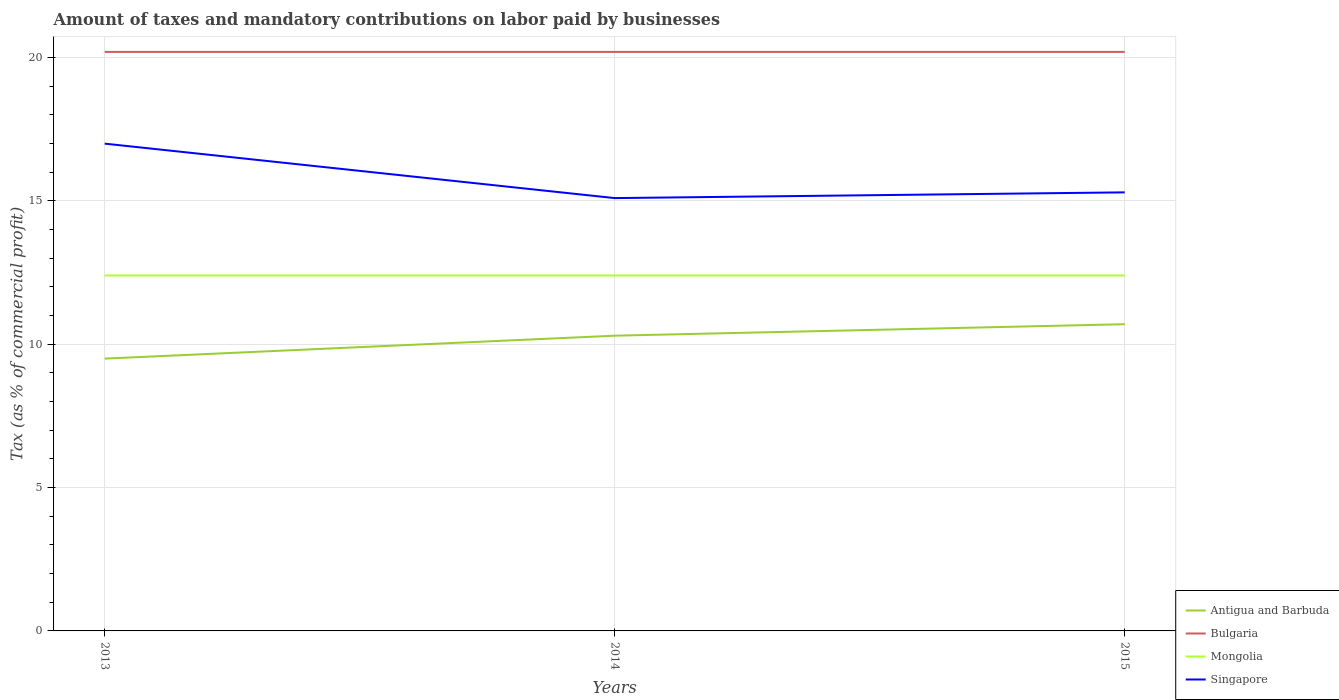What is the total percentage of taxes paid by businesses in Singapore in the graph?
Offer a very short reply. -0.2. What is the difference between the highest and the lowest percentage of taxes paid by businesses in Bulgaria?
Provide a succinct answer. 0. Is the percentage of taxes paid by businesses in Antigua and Barbuda strictly greater than the percentage of taxes paid by businesses in Mongolia over the years?
Ensure brevity in your answer.  Yes. Are the values on the major ticks of Y-axis written in scientific E-notation?
Provide a short and direct response. No. How many legend labels are there?
Provide a short and direct response. 4. What is the title of the graph?
Your answer should be compact. Amount of taxes and mandatory contributions on labor paid by businesses. Does "Bermuda" appear as one of the legend labels in the graph?
Provide a short and direct response. No. What is the label or title of the Y-axis?
Keep it short and to the point. Tax (as % of commercial profit). What is the Tax (as % of commercial profit) in Bulgaria in 2013?
Your answer should be very brief. 20.2. What is the Tax (as % of commercial profit) in Mongolia in 2013?
Offer a very short reply. 12.4. What is the Tax (as % of commercial profit) in Singapore in 2013?
Your answer should be compact. 17. What is the Tax (as % of commercial profit) of Antigua and Barbuda in 2014?
Keep it short and to the point. 10.3. What is the Tax (as % of commercial profit) of Bulgaria in 2014?
Make the answer very short. 20.2. What is the Tax (as % of commercial profit) of Mongolia in 2014?
Keep it short and to the point. 12.4. What is the Tax (as % of commercial profit) in Singapore in 2014?
Your answer should be very brief. 15.1. What is the Tax (as % of commercial profit) of Bulgaria in 2015?
Provide a short and direct response. 20.2. What is the Tax (as % of commercial profit) in Mongolia in 2015?
Keep it short and to the point. 12.4. Across all years, what is the maximum Tax (as % of commercial profit) in Bulgaria?
Provide a succinct answer. 20.2. Across all years, what is the maximum Tax (as % of commercial profit) in Mongolia?
Provide a succinct answer. 12.4. Across all years, what is the maximum Tax (as % of commercial profit) in Singapore?
Provide a succinct answer. 17. Across all years, what is the minimum Tax (as % of commercial profit) of Antigua and Barbuda?
Provide a succinct answer. 9.5. Across all years, what is the minimum Tax (as % of commercial profit) in Bulgaria?
Offer a very short reply. 20.2. Across all years, what is the minimum Tax (as % of commercial profit) in Singapore?
Your answer should be compact. 15.1. What is the total Tax (as % of commercial profit) in Antigua and Barbuda in the graph?
Provide a succinct answer. 30.5. What is the total Tax (as % of commercial profit) in Bulgaria in the graph?
Offer a terse response. 60.6. What is the total Tax (as % of commercial profit) in Mongolia in the graph?
Your response must be concise. 37.2. What is the total Tax (as % of commercial profit) of Singapore in the graph?
Your response must be concise. 47.4. What is the difference between the Tax (as % of commercial profit) of Mongolia in 2013 and that in 2014?
Offer a terse response. 0. What is the difference between the Tax (as % of commercial profit) of Singapore in 2013 and that in 2015?
Ensure brevity in your answer.  1.7. What is the difference between the Tax (as % of commercial profit) of Antigua and Barbuda in 2014 and that in 2015?
Ensure brevity in your answer.  -0.4. What is the difference between the Tax (as % of commercial profit) in Bulgaria in 2014 and that in 2015?
Provide a succinct answer. 0. What is the difference between the Tax (as % of commercial profit) in Singapore in 2014 and that in 2015?
Your response must be concise. -0.2. What is the difference between the Tax (as % of commercial profit) in Mongolia in 2013 and the Tax (as % of commercial profit) in Singapore in 2014?
Keep it short and to the point. -2.7. What is the difference between the Tax (as % of commercial profit) in Antigua and Barbuda in 2013 and the Tax (as % of commercial profit) in Bulgaria in 2015?
Provide a succinct answer. -10.7. What is the difference between the Tax (as % of commercial profit) in Antigua and Barbuda in 2013 and the Tax (as % of commercial profit) in Mongolia in 2015?
Offer a terse response. -2.9. What is the difference between the Tax (as % of commercial profit) in Antigua and Barbuda in 2014 and the Tax (as % of commercial profit) in Bulgaria in 2015?
Provide a succinct answer. -9.9. What is the difference between the Tax (as % of commercial profit) of Bulgaria in 2014 and the Tax (as % of commercial profit) of Mongolia in 2015?
Give a very brief answer. 7.8. What is the average Tax (as % of commercial profit) in Antigua and Barbuda per year?
Your answer should be compact. 10.17. What is the average Tax (as % of commercial profit) of Bulgaria per year?
Provide a succinct answer. 20.2. What is the average Tax (as % of commercial profit) of Singapore per year?
Your answer should be very brief. 15.8. In the year 2013, what is the difference between the Tax (as % of commercial profit) of Antigua and Barbuda and Tax (as % of commercial profit) of Singapore?
Provide a succinct answer. -7.5. In the year 2013, what is the difference between the Tax (as % of commercial profit) of Bulgaria and Tax (as % of commercial profit) of Singapore?
Give a very brief answer. 3.2. In the year 2014, what is the difference between the Tax (as % of commercial profit) in Antigua and Barbuda and Tax (as % of commercial profit) in Mongolia?
Your response must be concise. -2.1. In the year 2014, what is the difference between the Tax (as % of commercial profit) in Bulgaria and Tax (as % of commercial profit) in Mongolia?
Give a very brief answer. 7.8. In the year 2014, what is the difference between the Tax (as % of commercial profit) of Bulgaria and Tax (as % of commercial profit) of Singapore?
Provide a succinct answer. 5.1. In the year 2015, what is the difference between the Tax (as % of commercial profit) of Antigua and Barbuda and Tax (as % of commercial profit) of Bulgaria?
Keep it short and to the point. -9.5. In the year 2015, what is the difference between the Tax (as % of commercial profit) in Antigua and Barbuda and Tax (as % of commercial profit) in Mongolia?
Ensure brevity in your answer.  -1.7. In the year 2015, what is the difference between the Tax (as % of commercial profit) in Antigua and Barbuda and Tax (as % of commercial profit) in Singapore?
Your answer should be very brief. -4.6. In the year 2015, what is the difference between the Tax (as % of commercial profit) in Mongolia and Tax (as % of commercial profit) in Singapore?
Keep it short and to the point. -2.9. What is the ratio of the Tax (as % of commercial profit) in Antigua and Barbuda in 2013 to that in 2014?
Offer a terse response. 0.92. What is the ratio of the Tax (as % of commercial profit) of Singapore in 2013 to that in 2014?
Provide a succinct answer. 1.13. What is the ratio of the Tax (as % of commercial profit) of Antigua and Barbuda in 2013 to that in 2015?
Ensure brevity in your answer.  0.89. What is the ratio of the Tax (as % of commercial profit) of Mongolia in 2013 to that in 2015?
Provide a short and direct response. 1. What is the ratio of the Tax (as % of commercial profit) in Antigua and Barbuda in 2014 to that in 2015?
Make the answer very short. 0.96. What is the ratio of the Tax (as % of commercial profit) in Bulgaria in 2014 to that in 2015?
Ensure brevity in your answer.  1. What is the ratio of the Tax (as % of commercial profit) in Singapore in 2014 to that in 2015?
Offer a very short reply. 0.99. What is the difference between the highest and the second highest Tax (as % of commercial profit) of Antigua and Barbuda?
Keep it short and to the point. 0.4. What is the difference between the highest and the second highest Tax (as % of commercial profit) in Bulgaria?
Your answer should be very brief. 0. What is the difference between the highest and the lowest Tax (as % of commercial profit) in Bulgaria?
Keep it short and to the point. 0. 